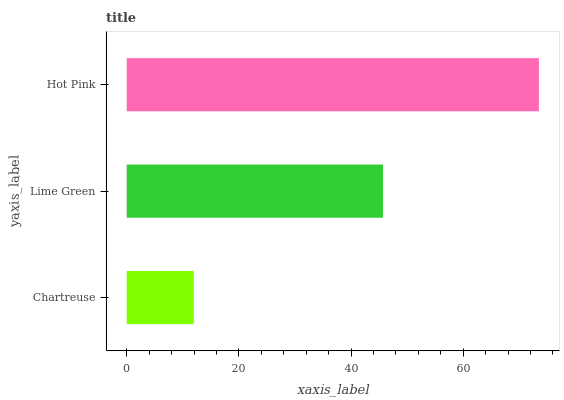Is Chartreuse the minimum?
Answer yes or no. Yes. Is Hot Pink the maximum?
Answer yes or no. Yes. Is Lime Green the minimum?
Answer yes or no. No. Is Lime Green the maximum?
Answer yes or no. No. Is Lime Green greater than Chartreuse?
Answer yes or no. Yes. Is Chartreuse less than Lime Green?
Answer yes or no. Yes. Is Chartreuse greater than Lime Green?
Answer yes or no. No. Is Lime Green less than Chartreuse?
Answer yes or no. No. Is Lime Green the high median?
Answer yes or no. Yes. Is Lime Green the low median?
Answer yes or no. Yes. Is Chartreuse the high median?
Answer yes or no. No. Is Chartreuse the low median?
Answer yes or no. No. 